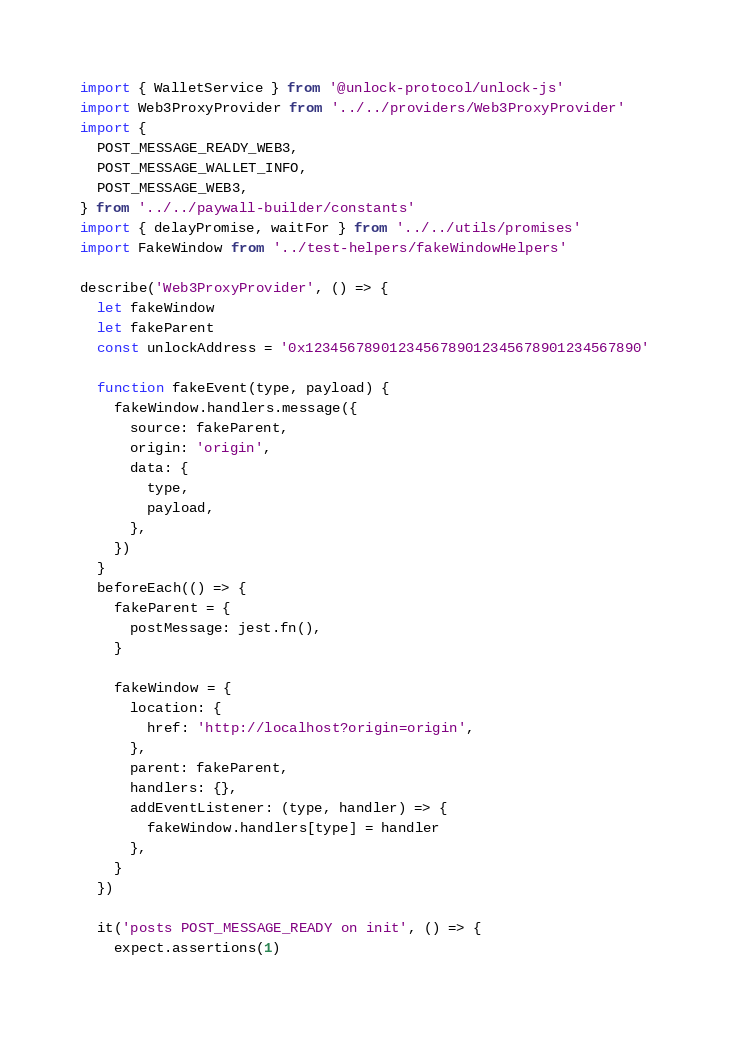Convert code to text. <code><loc_0><loc_0><loc_500><loc_500><_JavaScript_>import { WalletService } from '@unlock-protocol/unlock-js'
import Web3ProxyProvider from '../../providers/Web3ProxyProvider'
import {
  POST_MESSAGE_READY_WEB3,
  POST_MESSAGE_WALLET_INFO,
  POST_MESSAGE_WEB3,
} from '../../paywall-builder/constants'
import { delayPromise, waitFor } from '../../utils/promises'
import FakeWindow from '../test-helpers/fakeWindowHelpers'

describe('Web3ProxyProvider', () => {
  let fakeWindow
  let fakeParent
  const unlockAddress = '0x1234567890123456789012345678901234567890'

  function fakeEvent(type, payload) {
    fakeWindow.handlers.message({
      source: fakeParent,
      origin: 'origin',
      data: {
        type,
        payload,
      },
    })
  }
  beforeEach(() => {
    fakeParent = {
      postMessage: jest.fn(),
    }

    fakeWindow = {
      location: {
        href: 'http://localhost?origin=origin',
      },
      parent: fakeParent,
      handlers: {},
      addEventListener: (type, handler) => {
        fakeWindow.handlers[type] = handler
      },
    }
  })

  it('posts POST_MESSAGE_READY on init', () => {
    expect.assertions(1)</code> 